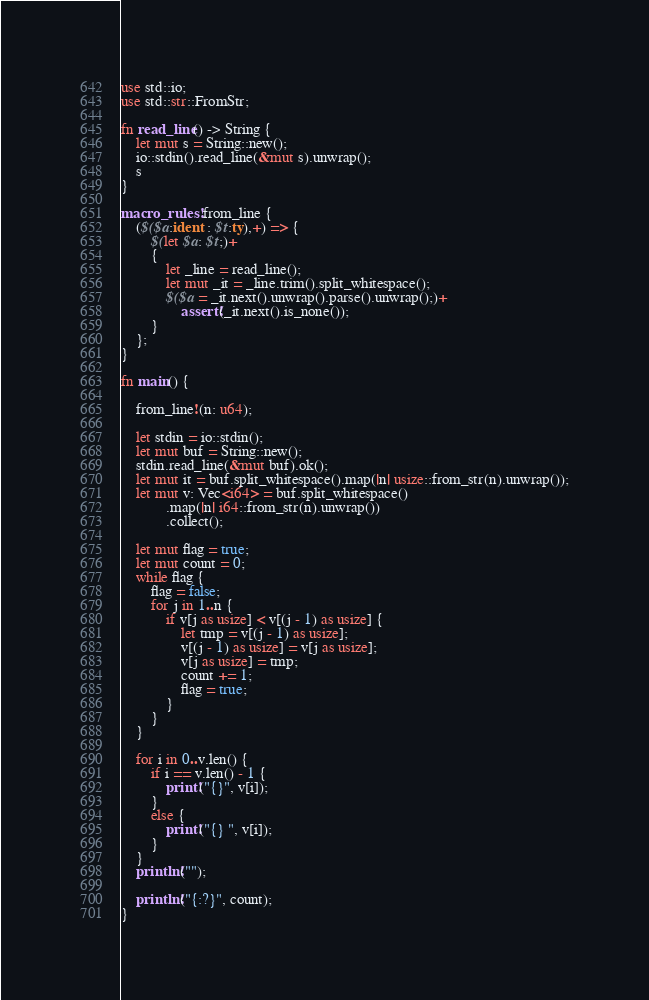Convert code to text. <code><loc_0><loc_0><loc_500><loc_500><_Rust_>use std::io;
use std::str::FromStr;

fn read_line() -> String {
    let mut s = String::new();
    io::stdin().read_line(&mut s).unwrap();
    s
}

macro_rules! from_line {
    ($($a:ident : $t:ty),+) => {
        $(let $a: $t;)+
        {
            let _line = read_line();
            let mut _it = _line.trim().split_whitespace();
            $($a = _it.next().unwrap().parse().unwrap();)+
                assert!(_it.next().is_none());
        }
    };
}

fn main() {

    from_line!(n: u64);

    let stdin = io::stdin();
    let mut buf = String::new();
    stdin.read_line(&mut buf).ok();
    let mut it = buf.split_whitespace().map(|n| usize::from_str(n).unwrap());
    let mut v: Vec<i64> = buf.split_whitespace()
            .map(|n| i64::from_str(n).unwrap())
            .collect();

    let mut flag = true;
    let mut count = 0;
    while flag {
        flag = false;
        for j in 1..n {
            if v[j as usize] < v[(j - 1) as usize] {
                let tmp = v[(j - 1) as usize];
                v[(j - 1) as usize] = v[j as usize];
                v[j as usize] = tmp;
                count += 1;
                flag = true;
            }
        }
    }

    for i in 0..v.len() {
        if i == v.len() - 1 {
            print!("{}", v[i]);
        }
        else {
            print!("{} ", v[i]);
        }
    }
    println!("");

    println!("{:?}", count);
}

</code> 